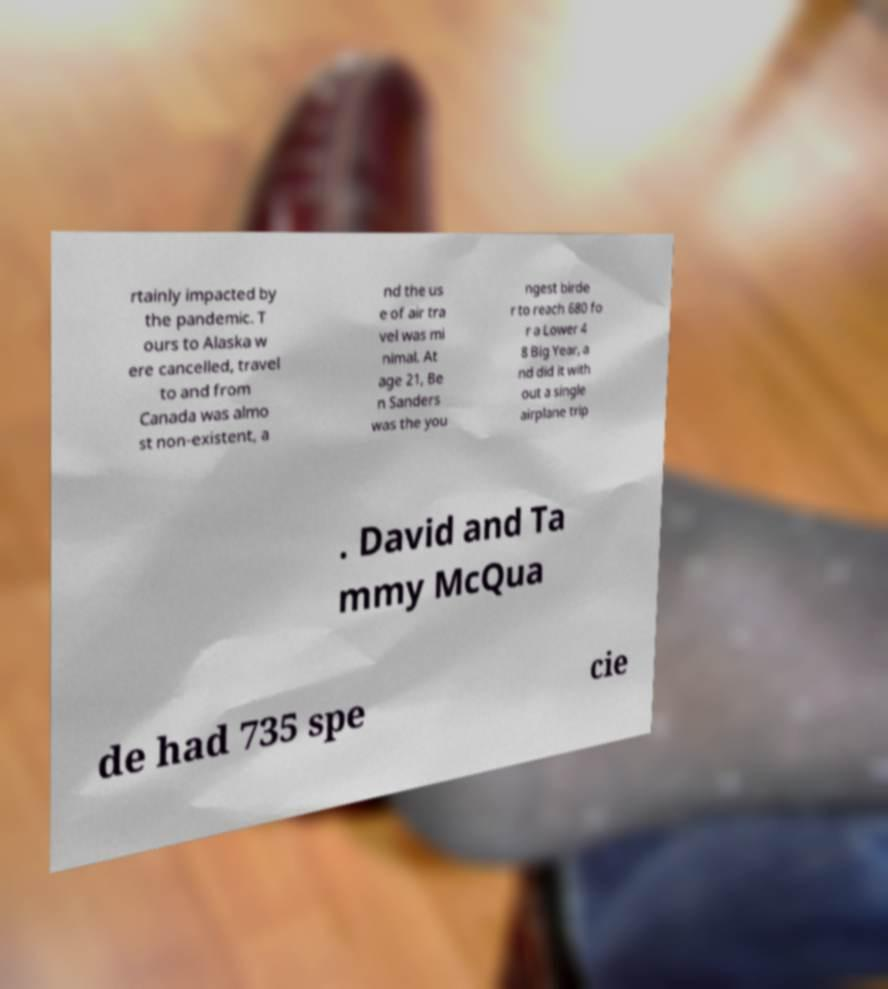For documentation purposes, I need the text within this image transcribed. Could you provide that? rtainly impacted by the pandemic. T ours to Alaska w ere cancelled, travel to and from Canada was almo st non-existent, a nd the us e of air tra vel was mi nimal. At age 21, Be n Sanders was the you ngest birde r to reach 680 fo r a Lower 4 8 Big Year, a nd did it with out a single airplane trip . David and Ta mmy McQua de had 735 spe cie 